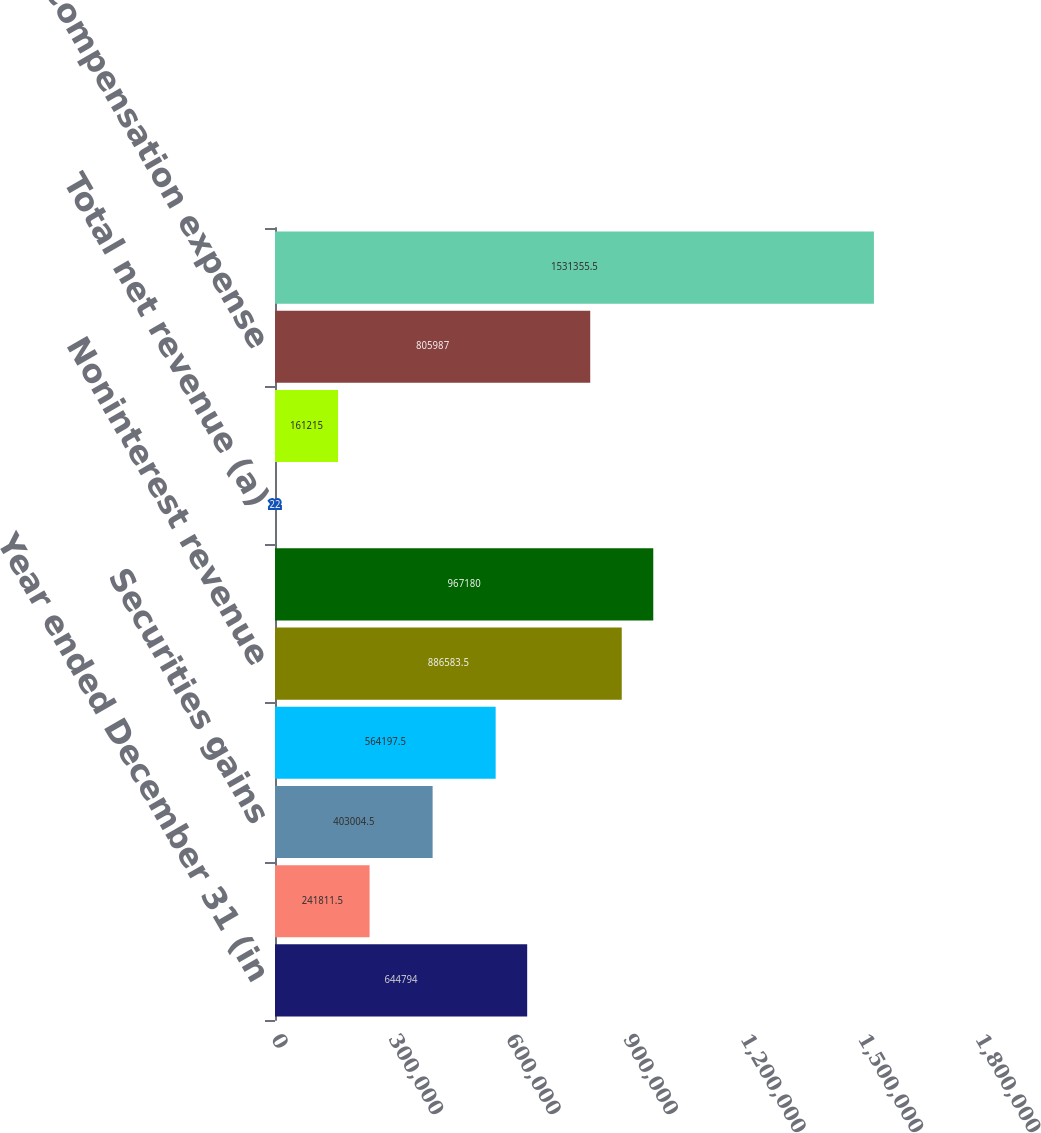Convert chart to OTSL. <chart><loc_0><loc_0><loc_500><loc_500><bar_chart><fcel>Year ended December 31 (in<fcel>Principal transactions<fcel>Securities gains<fcel>All other income<fcel>Noninterest revenue<fcel>Net interest income<fcel>Total net revenue (a)<fcel>Provision for credit losses<fcel>Compensation expense<fcel>Noncompensation expense (b)<nl><fcel>644794<fcel>241812<fcel>403004<fcel>564198<fcel>886584<fcel>967180<fcel>22<fcel>161215<fcel>805987<fcel>1.53136e+06<nl></chart> 